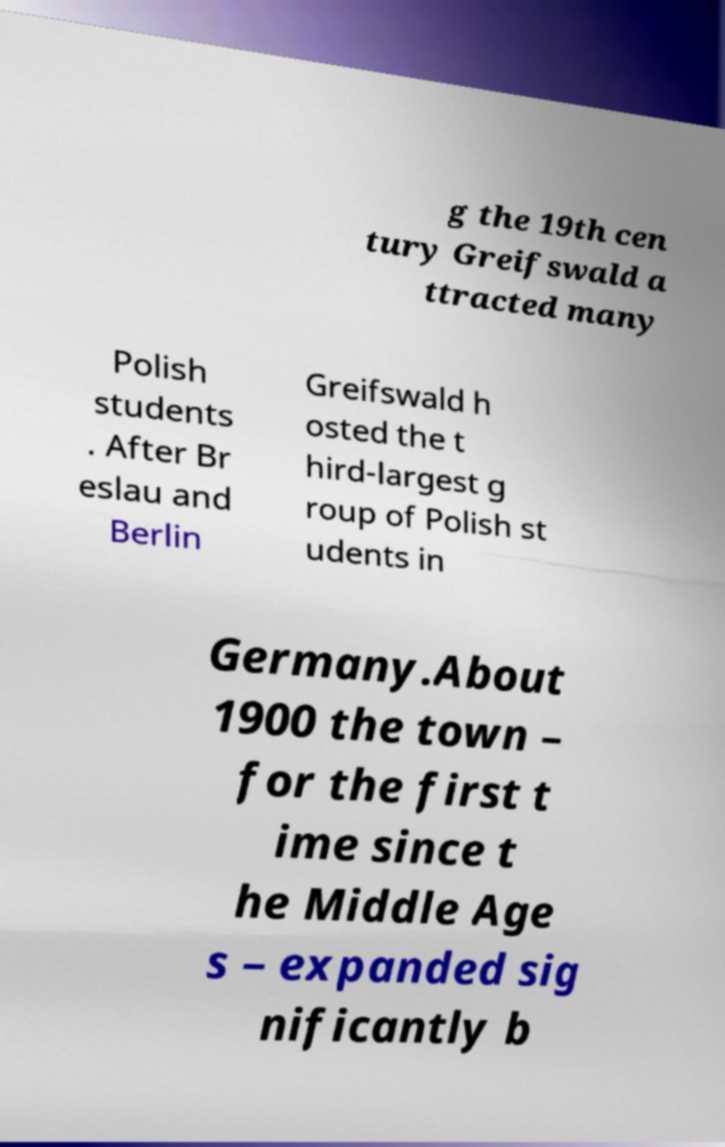I need the written content from this picture converted into text. Can you do that? g the 19th cen tury Greifswald a ttracted many Polish students . After Br eslau and Berlin Greifswald h osted the t hird-largest g roup of Polish st udents in Germany.About 1900 the town – for the first t ime since t he Middle Age s – expanded sig nificantly b 